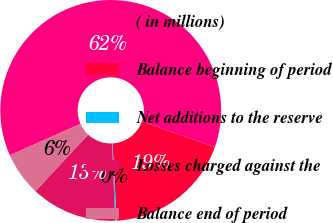Convert chart. <chart><loc_0><loc_0><loc_500><loc_500><pie_chart><fcel>( in millions)<fcel>Balance beginning of period<fcel>Net additions to the reserve<fcel>Losses charged against the<fcel>Balance end of period<nl><fcel>62.04%<fcel>18.76%<fcel>0.22%<fcel>12.58%<fcel>6.4%<nl></chart> 